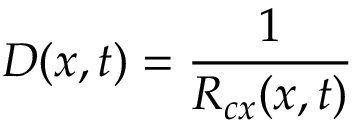Convert formula to latex. <formula><loc_0><loc_0><loc_500><loc_500>D ( x , t ) = \frac { 1 } { R _ { c x } ( x , t ) }</formula> 